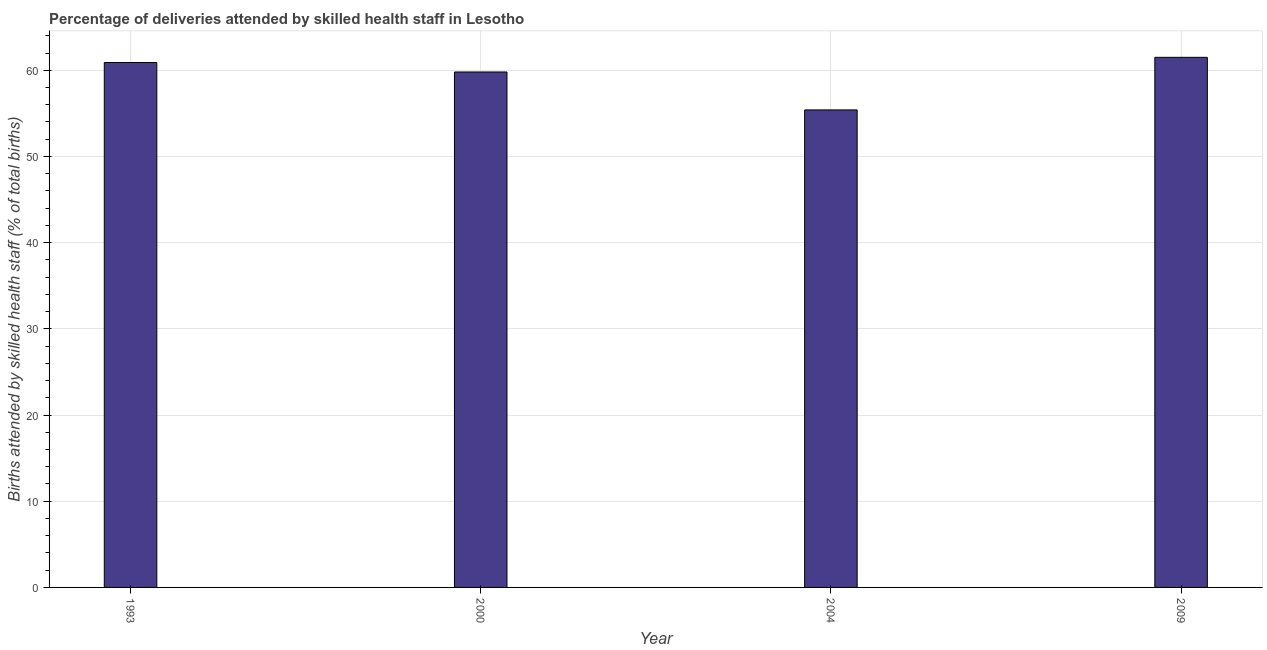What is the title of the graph?
Offer a terse response. Percentage of deliveries attended by skilled health staff in Lesotho. What is the label or title of the X-axis?
Provide a succinct answer. Year. What is the label or title of the Y-axis?
Provide a short and direct response. Births attended by skilled health staff (% of total births). What is the number of births attended by skilled health staff in 2004?
Provide a short and direct response. 55.4. Across all years, what is the maximum number of births attended by skilled health staff?
Your response must be concise. 61.5. Across all years, what is the minimum number of births attended by skilled health staff?
Provide a succinct answer. 55.4. What is the sum of the number of births attended by skilled health staff?
Keep it short and to the point. 237.6. What is the difference between the number of births attended by skilled health staff in 2000 and 2004?
Give a very brief answer. 4.4. What is the average number of births attended by skilled health staff per year?
Give a very brief answer. 59.4. What is the median number of births attended by skilled health staff?
Ensure brevity in your answer.  60.35. In how many years, is the number of births attended by skilled health staff greater than 2 %?
Ensure brevity in your answer.  4. Do a majority of the years between 2000 and 2004 (inclusive) have number of births attended by skilled health staff greater than 58 %?
Your answer should be compact. No. What is the ratio of the number of births attended by skilled health staff in 1993 to that in 2004?
Offer a terse response. 1.1. Is the number of births attended by skilled health staff in 1993 less than that in 2000?
Keep it short and to the point. No. Is the difference between the number of births attended by skilled health staff in 2000 and 2009 greater than the difference between any two years?
Your response must be concise. No. Are all the bars in the graph horizontal?
Keep it short and to the point. No. What is the difference between two consecutive major ticks on the Y-axis?
Offer a terse response. 10. What is the Births attended by skilled health staff (% of total births) in 1993?
Your answer should be very brief. 60.9. What is the Births attended by skilled health staff (% of total births) in 2000?
Ensure brevity in your answer.  59.8. What is the Births attended by skilled health staff (% of total births) in 2004?
Your answer should be very brief. 55.4. What is the Births attended by skilled health staff (% of total births) in 2009?
Your response must be concise. 61.5. What is the difference between the Births attended by skilled health staff (% of total births) in 1993 and 2000?
Offer a very short reply. 1.1. What is the difference between the Births attended by skilled health staff (% of total births) in 1993 and 2009?
Provide a short and direct response. -0.6. What is the difference between the Births attended by skilled health staff (% of total births) in 2000 and 2004?
Offer a terse response. 4.4. What is the difference between the Births attended by skilled health staff (% of total births) in 2000 and 2009?
Offer a terse response. -1.7. What is the ratio of the Births attended by skilled health staff (% of total births) in 1993 to that in 2000?
Keep it short and to the point. 1.02. What is the ratio of the Births attended by skilled health staff (% of total births) in 1993 to that in 2004?
Provide a short and direct response. 1.1. What is the ratio of the Births attended by skilled health staff (% of total births) in 2000 to that in 2004?
Provide a short and direct response. 1.08. What is the ratio of the Births attended by skilled health staff (% of total births) in 2004 to that in 2009?
Give a very brief answer. 0.9. 